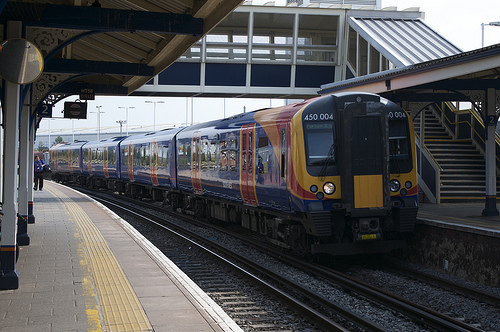Please provide the bounding box coordinate of the region this sentence describes: man on a train platform. A man on a train platform is captured within the coordinates [0.07, 0.48, 0.1, 0.55]. This area depicts an individual possibly waiting for his train, immersed in the daily routine of commute. 